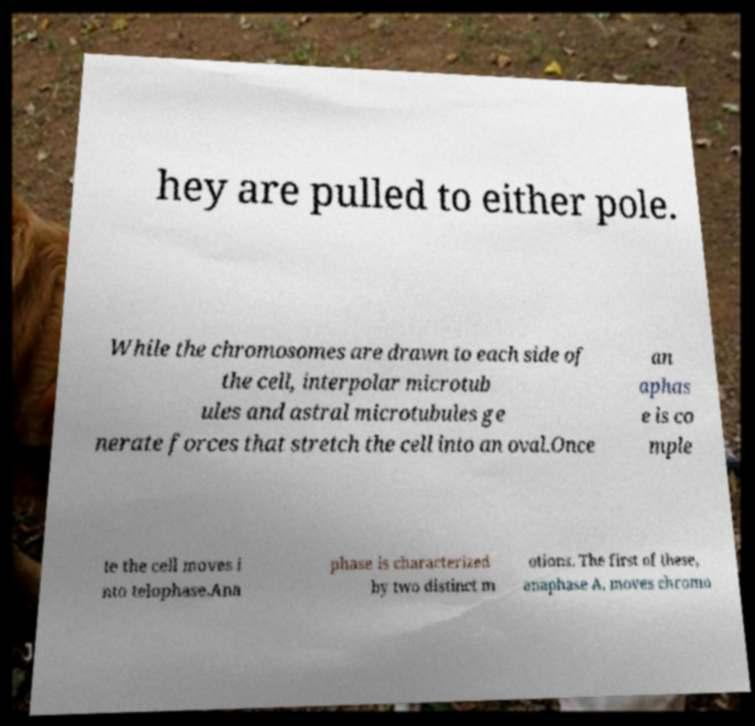What messages or text are displayed in this image? I need them in a readable, typed format. hey are pulled to either pole. While the chromosomes are drawn to each side of the cell, interpolar microtub ules and astral microtubules ge nerate forces that stretch the cell into an oval.Once an aphas e is co mple te the cell moves i nto telophase.Ana phase is characterized by two distinct m otions. The first of these, anaphase A, moves chromo 